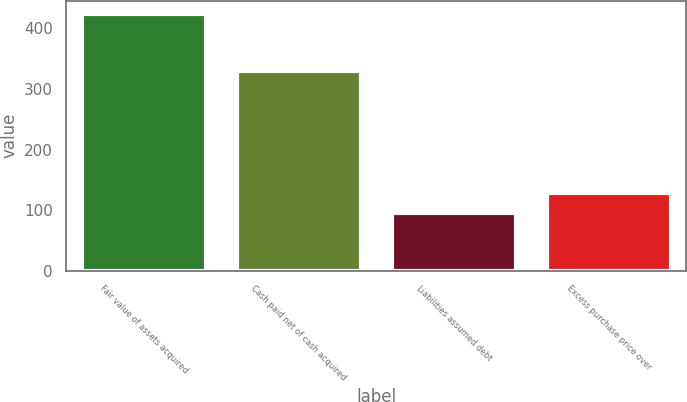<chart> <loc_0><loc_0><loc_500><loc_500><bar_chart><fcel>Fair value of assets acquired<fcel>Cash paid net of cash acquired<fcel>Liabilities assumed debt<fcel>Excess purchase price over<nl><fcel>424.6<fcel>329.7<fcel>94.9<fcel>127.87<nl></chart> 